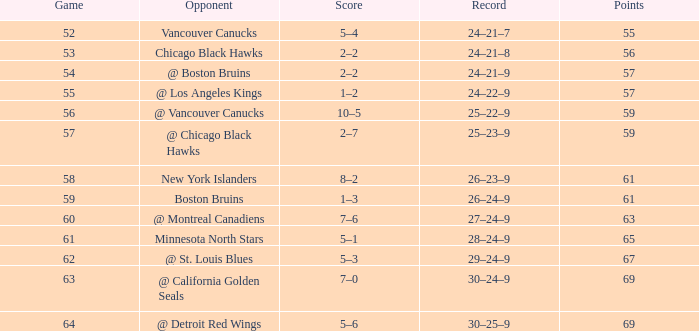How many games have a record of 30–25–9 and more points than 69? 0.0. 